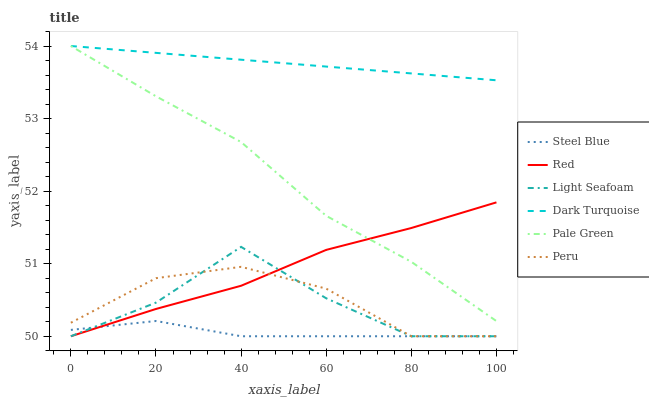Does Steel Blue have the minimum area under the curve?
Answer yes or no. Yes. Does Dark Turquoise have the maximum area under the curve?
Answer yes or no. Yes. Does Pale Green have the minimum area under the curve?
Answer yes or no. No. Does Pale Green have the maximum area under the curve?
Answer yes or no. No. Is Dark Turquoise the smoothest?
Answer yes or no. Yes. Is Light Seafoam the roughest?
Answer yes or no. Yes. Is Steel Blue the smoothest?
Answer yes or no. No. Is Steel Blue the roughest?
Answer yes or no. No. Does Steel Blue have the lowest value?
Answer yes or no. Yes. Does Pale Green have the lowest value?
Answer yes or no. No. Does Pale Green have the highest value?
Answer yes or no. Yes. Does Steel Blue have the highest value?
Answer yes or no. No. Is Red less than Dark Turquoise?
Answer yes or no. Yes. Is Dark Turquoise greater than Red?
Answer yes or no. Yes. Does Light Seafoam intersect Peru?
Answer yes or no. Yes. Is Light Seafoam less than Peru?
Answer yes or no. No. Is Light Seafoam greater than Peru?
Answer yes or no. No. Does Red intersect Dark Turquoise?
Answer yes or no. No. 